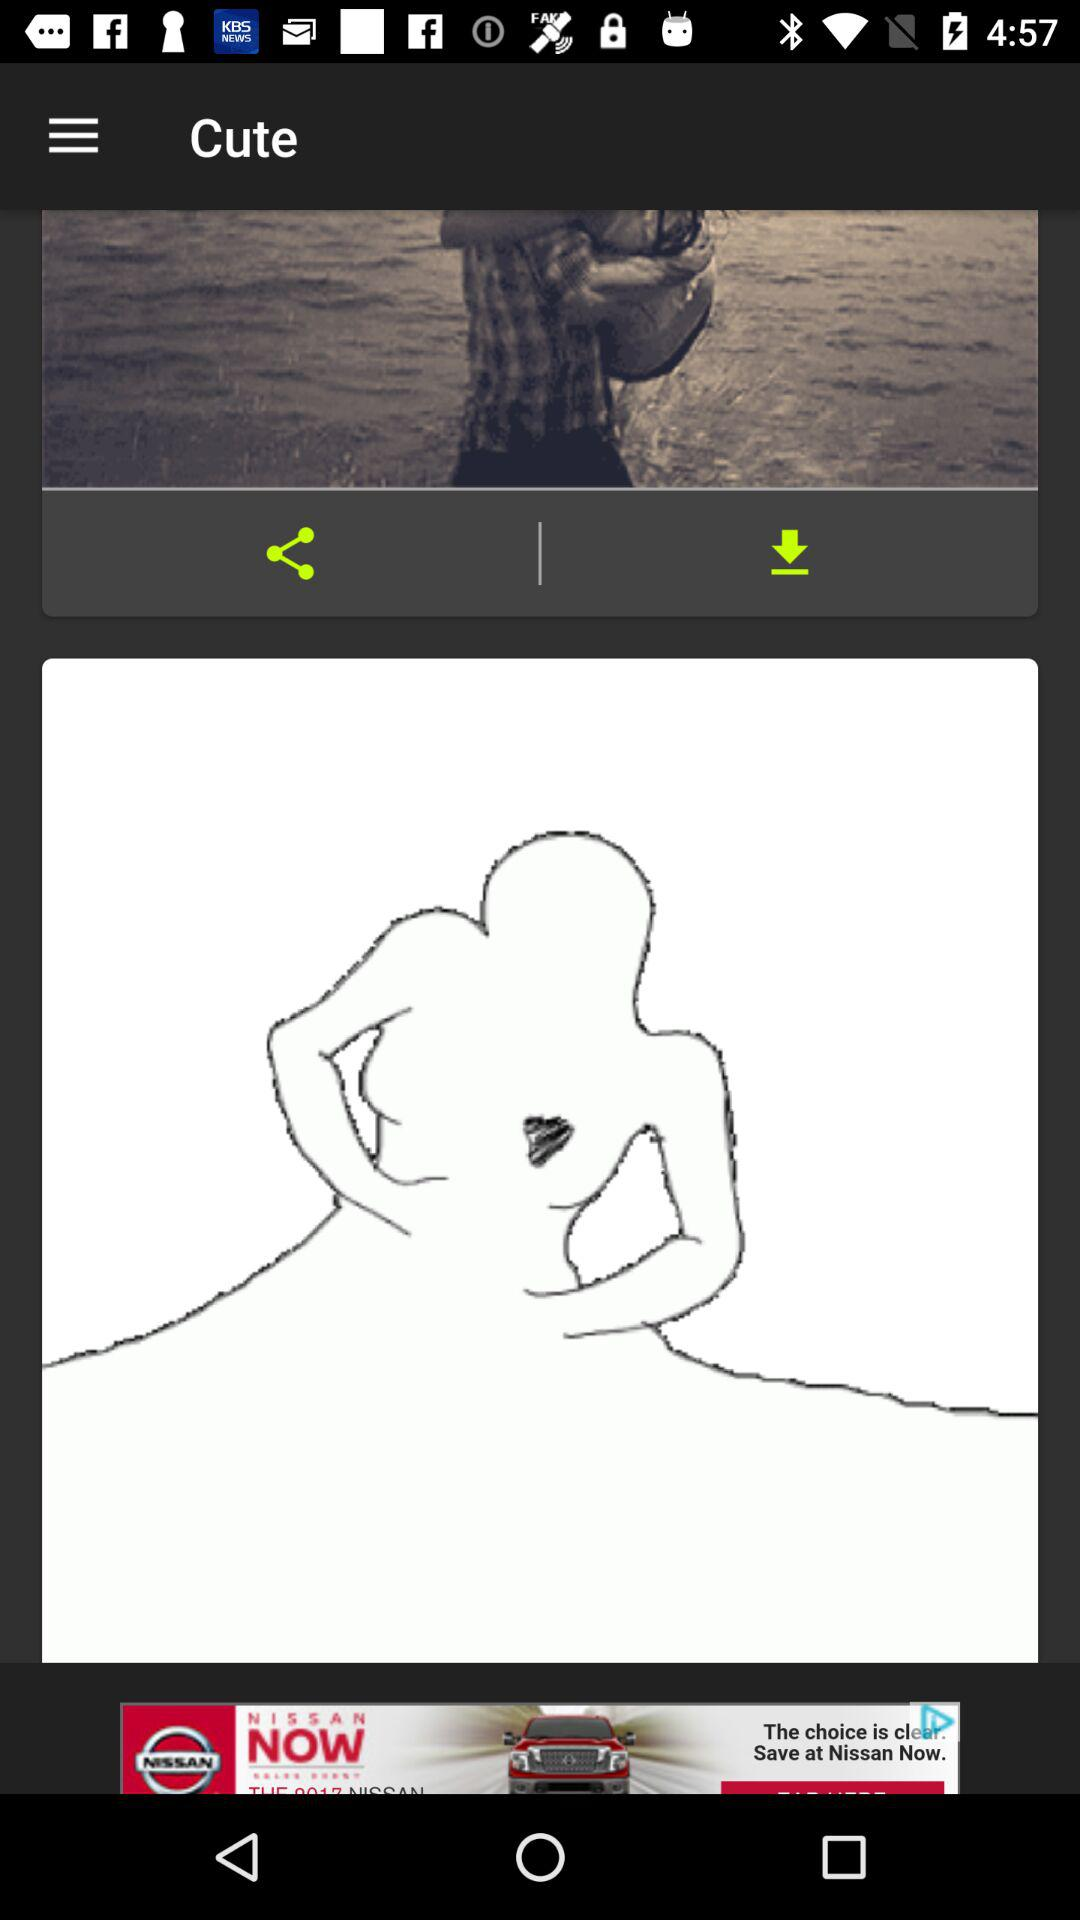What is the application name? The application name is "Cute". 